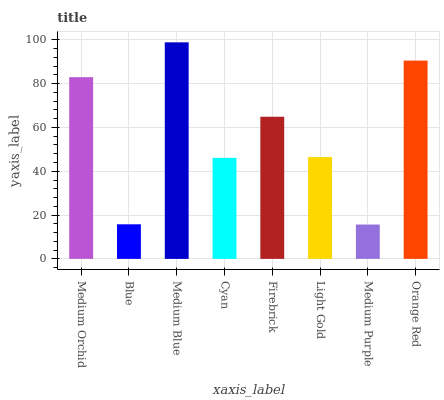Is Medium Purple the minimum?
Answer yes or no. Yes. Is Medium Blue the maximum?
Answer yes or no. Yes. Is Blue the minimum?
Answer yes or no. No. Is Blue the maximum?
Answer yes or no. No. Is Medium Orchid greater than Blue?
Answer yes or no. Yes. Is Blue less than Medium Orchid?
Answer yes or no. Yes. Is Blue greater than Medium Orchid?
Answer yes or no. No. Is Medium Orchid less than Blue?
Answer yes or no. No. Is Firebrick the high median?
Answer yes or no. Yes. Is Light Gold the low median?
Answer yes or no. Yes. Is Light Gold the high median?
Answer yes or no. No. Is Orange Red the low median?
Answer yes or no. No. 